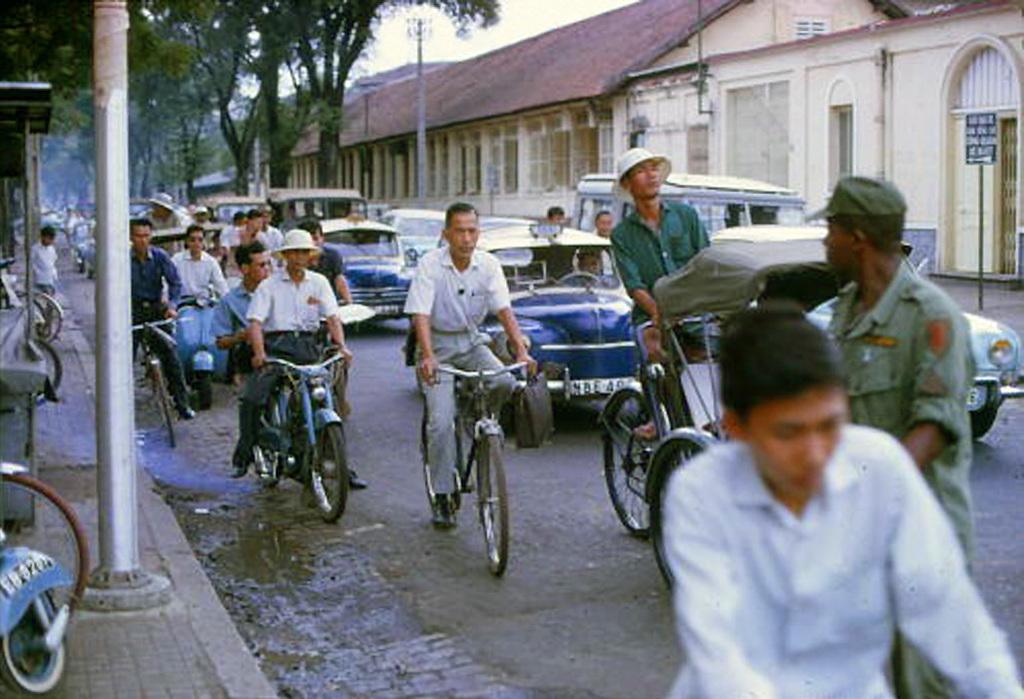In one or two sentences, can you explain what this image depicts? There are many vehicles on the road. Some people are riding bicycles,some people are riding motorcycles. This looks like a vehicle wheel. At background I can see trees,current pole and buildings. 